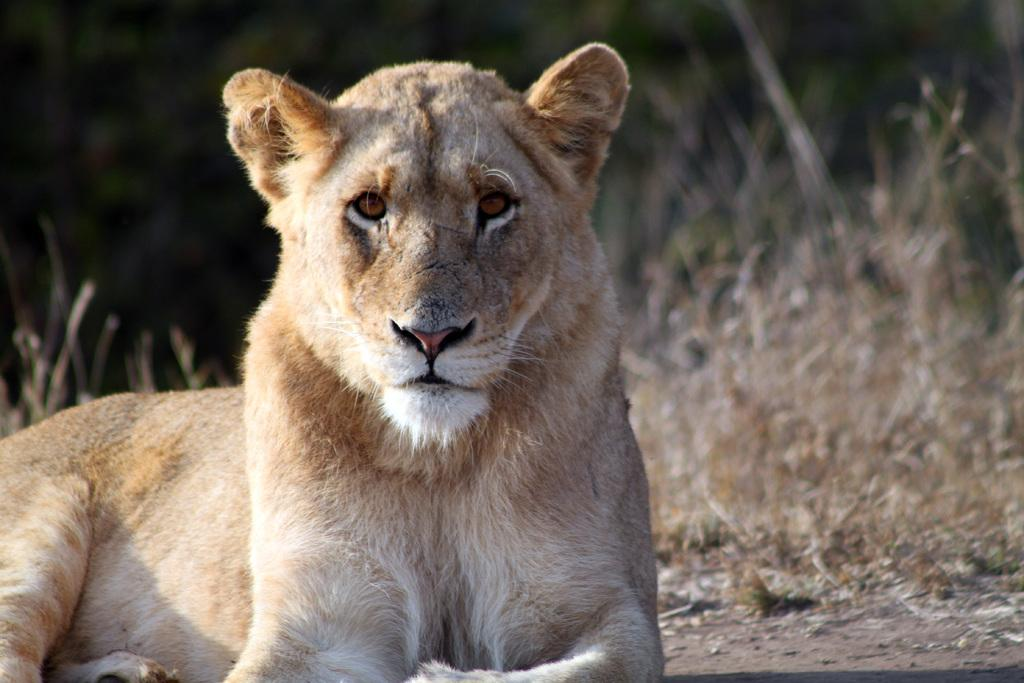What animal is the main subject of the image? There is a lion in the image. What position is the lion in? The lion is sitting on the ground. What type of environment is depicted in the background? The background appears to be dried grass. Where is the shelf located in the image? There is no shelf present in the image. What type of geese can be seen in the image? There are no geese present in the image. 